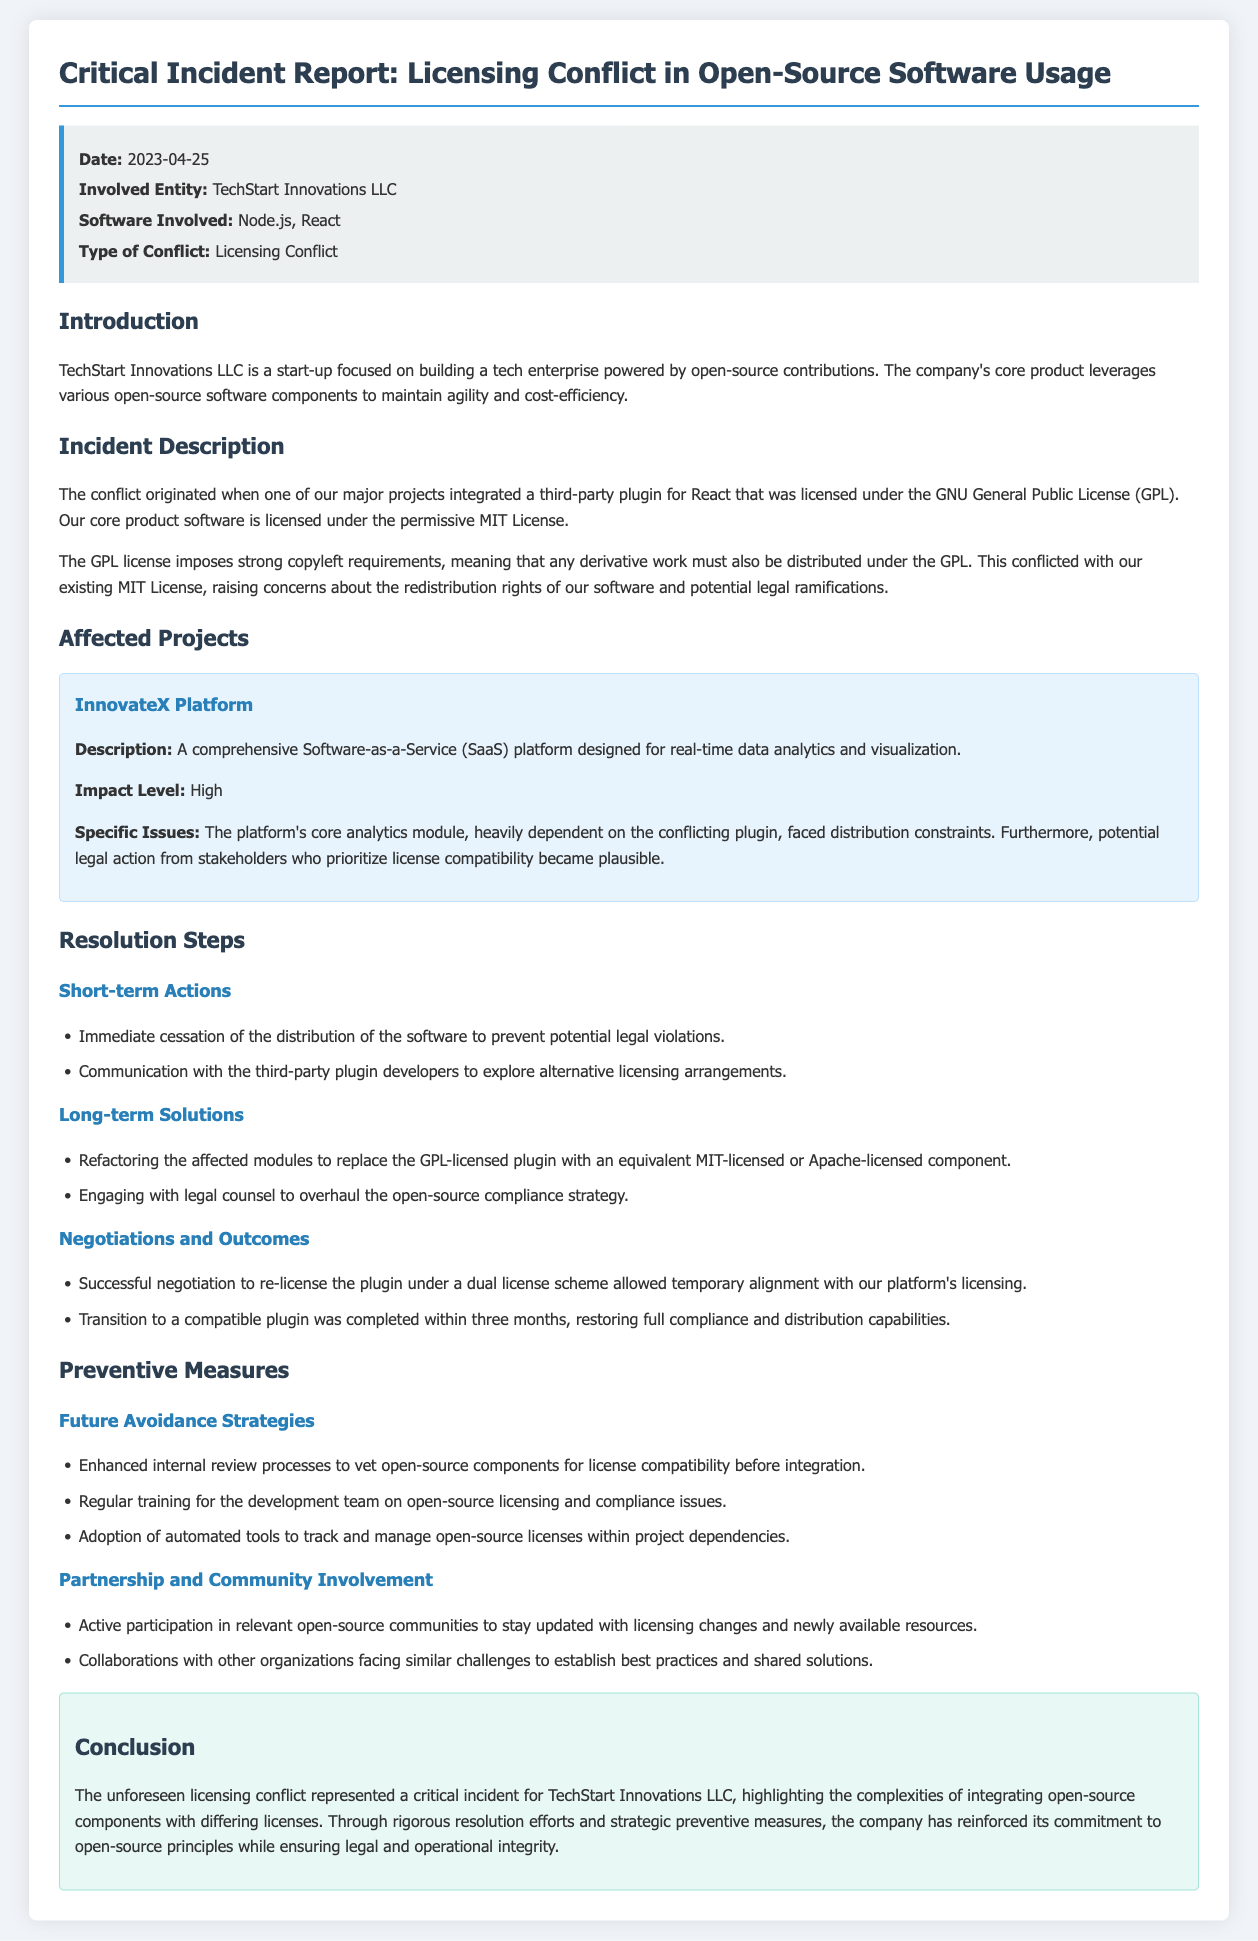what is the date of the incident? The date of the incident is mentioned in the summary section of the document.
Answer: 2023-04-25 who is the involved entity? The involved entity is detailed in the summary section of the document.
Answer: TechStart Innovations LLC what type of license did the third-party plugin use? The type of license for the third-party plugin is specified in the incident description.
Answer: GNU General Public License (GPL) what was the impact level on the InnovateX Platform? The impact level is discussed in the affected projects section of the document.
Answer: High what were the short-term actions taken to resolve the conflict? The short-term actions are listed in the resolution steps section of the document.
Answer: Immediate cessation of the distribution of the software what long-term solution was implemented regarding the affected modules? The long-term solution is specified in the resolution steps section.
Answer: Refactoring the affected modules what major legal implication arose from the licensing conflict? The legal implications are explained in the incident description.
Answer: Potential legal action from stakeholders what is one future avoidance strategy mentioned? Future avoidance strategies are listed in the preventive measures section.
Answer: Enhanced internal review processes which platform was affected by this licensing conflict? The affected platform is identified in the affected projects section.
Answer: InnovateX Platform how long did it take to complete the transition to a compatible plugin? The duration for the transition is specified in the negotiations and outcomes section.
Answer: Three months 